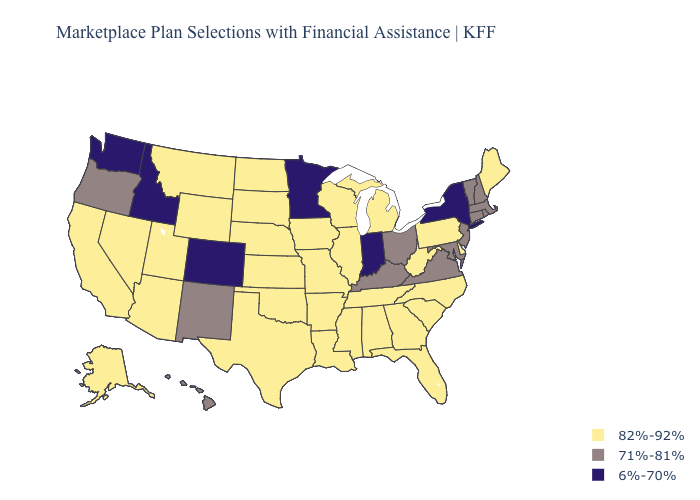Name the states that have a value in the range 71%-81%?
Short answer required. Connecticut, Hawaii, Kentucky, Maryland, Massachusetts, New Hampshire, New Jersey, New Mexico, Ohio, Oregon, Rhode Island, Vermont, Virginia. How many symbols are there in the legend?
Concise answer only. 3. What is the lowest value in states that border Arkansas?
Give a very brief answer. 82%-92%. What is the highest value in states that border Pennsylvania?
Be succinct. 82%-92%. What is the lowest value in the USA?
Concise answer only. 6%-70%. What is the lowest value in the USA?
Write a very short answer. 6%-70%. Among the states that border Colorado , which have the lowest value?
Keep it brief. New Mexico. Is the legend a continuous bar?
Be succinct. No. Does the first symbol in the legend represent the smallest category?
Answer briefly. No. Which states have the lowest value in the MidWest?
Write a very short answer. Indiana, Minnesota. How many symbols are there in the legend?
Short answer required. 3. What is the highest value in the Northeast ?
Answer briefly. 82%-92%. What is the value of Oklahoma?
Short answer required. 82%-92%. Name the states that have a value in the range 82%-92%?
Write a very short answer. Alabama, Alaska, Arizona, Arkansas, California, Delaware, Florida, Georgia, Illinois, Iowa, Kansas, Louisiana, Maine, Michigan, Mississippi, Missouri, Montana, Nebraska, Nevada, North Carolina, North Dakota, Oklahoma, Pennsylvania, South Carolina, South Dakota, Tennessee, Texas, Utah, West Virginia, Wisconsin, Wyoming. Name the states that have a value in the range 6%-70%?
Answer briefly. Colorado, Idaho, Indiana, Minnesota, New York, Washington. 